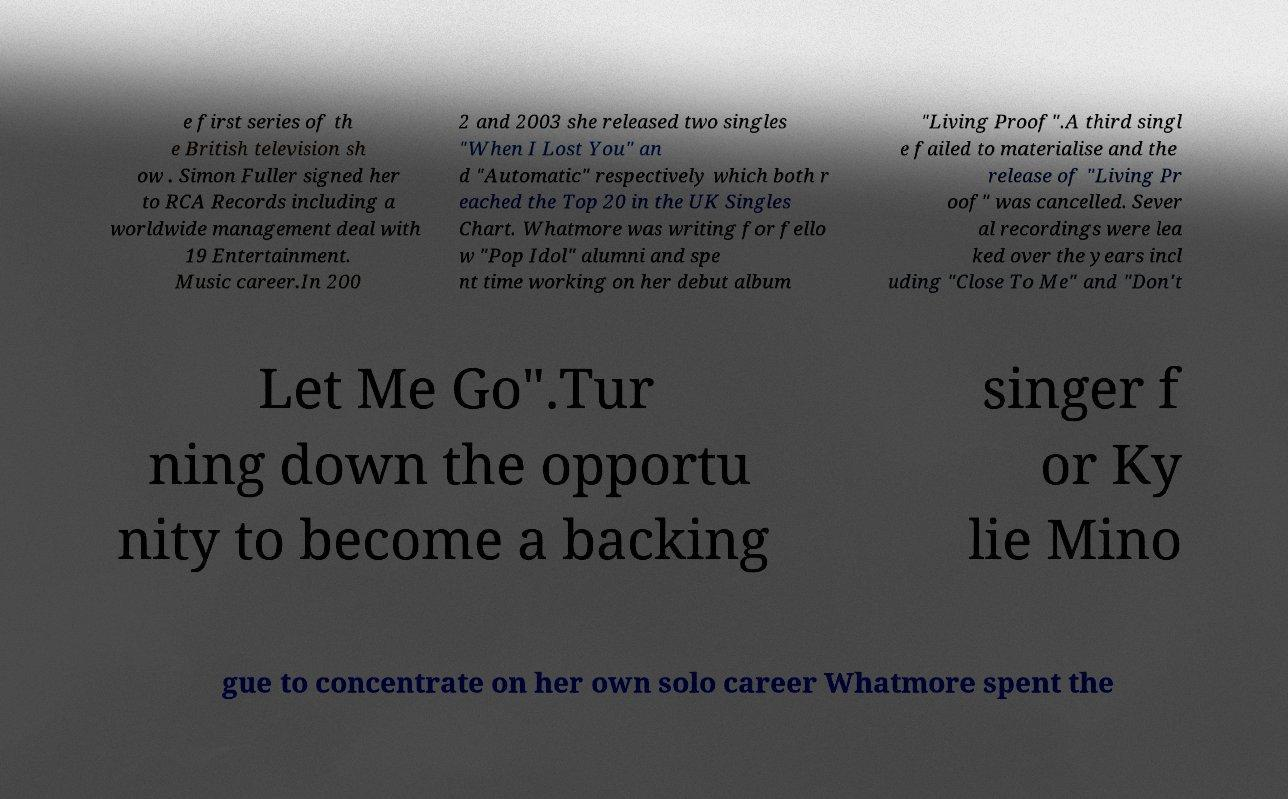I need the written content from this picture converted into text. Can you do that? e first series of th e British television sh ow . Simon Fuller signed her to RCA Records including a worldwide management deal with 19 Entertainment. Music career.In 200 2 and 2003 she released two singles "When I Lost You" an d "Automatic" respectively which both r eached the Top 20 in the UK Singles Chart. Whatmore was writing for fello w "Pop Idol" alumni and spe nt time working on her debut album "Living Proof".A third singl e failed to materialise and the release of "Living Pr oof" was cancelled. Sever al recordings were lea ked over the years incl uding "Close To Me" and "Don't Let Me Go".Tur ning down the opportu nity to become a backing singer f or Ky lie Mino gue to concentrate on her own solo career Whatmore spent the 